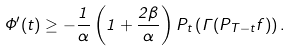Convert formula to latex. <formula><loc_0><loc_0><loc_500><loc_500>\Phi ^ { \prime } ( t ) \geq - \frac { 1 } { \alpha } \left ( 1 + \frac { 2 \beta } { \alpha } \right ) P _ { t } \left ( \Gamma ( P _ { T - t } f ) \right ) .</formula> 